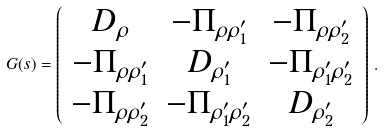<formula> <loc_0><loc_0><loc_500><loc_500>G ( s ) = \left ( \begin{array} { c c c } D _ { \rho } & - \Pi _ { \rho \rho ^ { \prime } _ { 1 } } & - \Pi _ { \rho \rho ^ { \prime } _ { 2 } } \\ - \Pi _ { \rho \rho ^ { \prime } _ { 1 } } & D _ { \rho ^ { \prime } _ { 1 } } & - \Pi _ { \rho ^ { \prime } _ { 1 } \rho ^ { \prime } _ { 2 } } \\ - \Pi _ { \rho \rho ^ { \prime } _ { 2 } } & - \Pi _ { \rho ^ { \prime } _ { 1 } \rho ^ { \prime } _ { 2 } } & D _ { \rho ^ { \prime } _ { 2 } } \end{array} \right ) \, .</formula> 